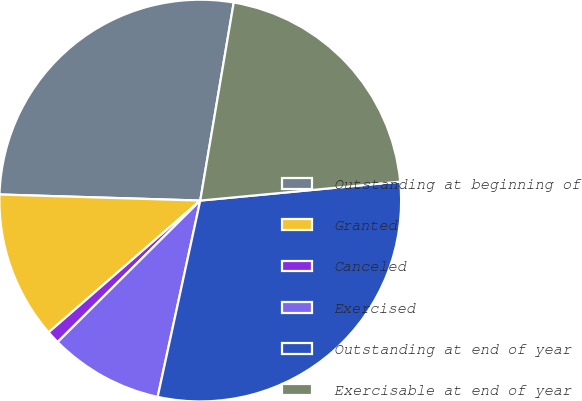<chart> <loc_0><loc_0><loc_500><loc_500><pie_chart><fcel>Outstanding at beginning of<fcel>Granted<fcel>Canceled<fcel>Exercised<fcel>Outstanding at end of year<fcel>Exercisable at end of year<nl><fcel>27.18%<fcel>11.87%<fcel>1.05%<fcel>9.16%<fcel>29.9%<fcel>20.83%<nl></chart> 